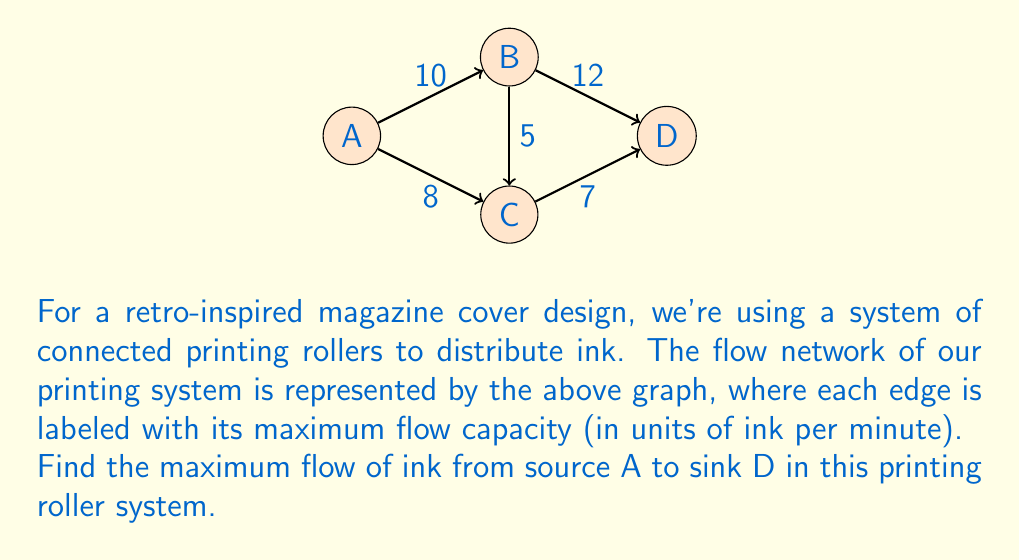Show me your answer to this math problem. To solve this maximum flow problem, we'll use the Ford-Fulkerson algorithm:

1) Initialize flow to 0 for all edges.

2) Find an augmenting path from A to D:
   Path 1: A → B → D (min capacity: 10)
   Increase flow by 10:
   A → B: 10/10
   B → D: 10/12

3) Find another augmenting path:
   Path 2: A → C → D (min capacity: 7)
   Increase flow by 7:
   A → C: 7/8
   C → D: 7/7

4) Find another augmenting path:
   Path 3: A → C → B → D (min capacity: 1)
   Increase flow by 1:
   A → C: 8/8
   C → B: 1/5
   B → D: 11/12

5) No more augmenting paths exist.

The maximum flow is the sum of all flows out of A:
$$\text{Max Flow} = 10 + 8 = 18$$

We can verify this by checking the total flow into D:
$$\text{Flow into D} = 11 + 7 = 18$$
Answer: 18 units of ink per minute 